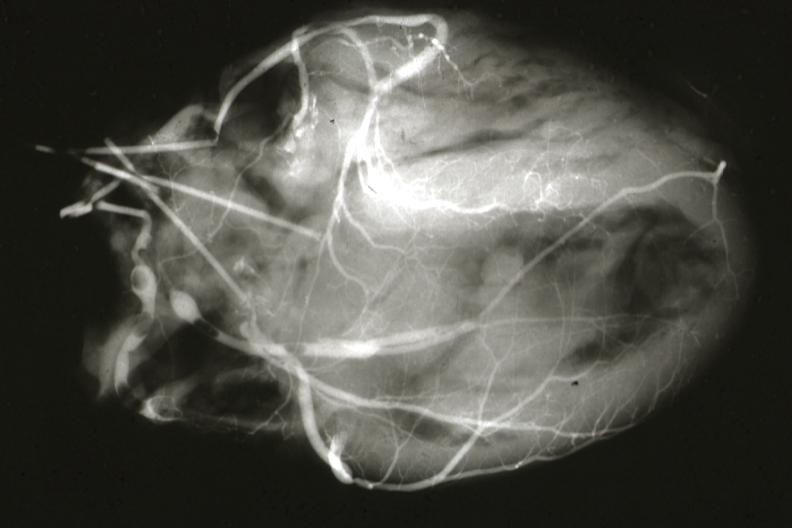s vessel present?
Answer the question using a single word or phrase. No 